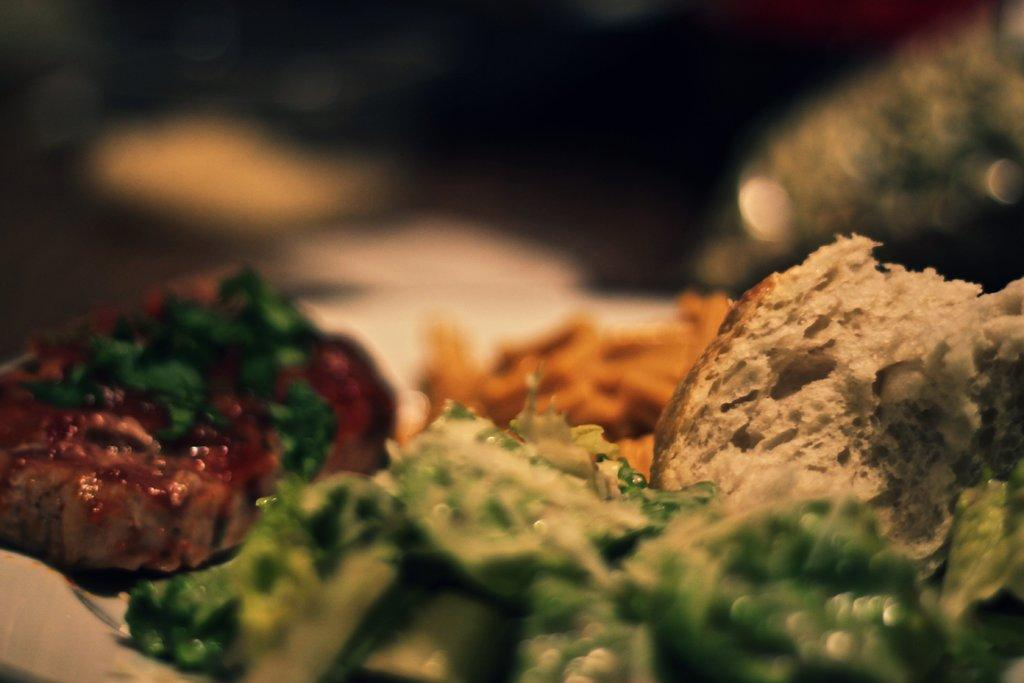What types of objects can be seen in the image? There are food items in the image. Can you describe the background of the image? The background of the image is blurred. Where is the hen located in the image? There is no hen present in the image. What type of nail is being used to lift the food items in the image? There are no nails or lifting actions involved with the food items in the image. 